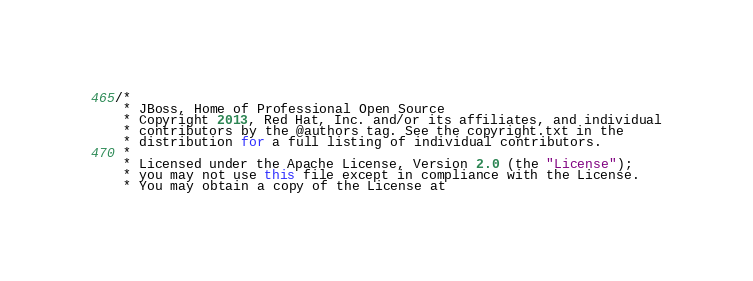Convert code to text. <code><loc_0><loc_0><loc_500><loc_500><_Java_>/*
 * JBoss, Home of Professional Open Source
 * Copyright 2013, Red Hat, Inc. and/or its affiliates, and individual
 * contributors by the @authors tag. See the copyright.txt in the
 * distribution for a full listing of individual contributors.
 *
 * Licensed under the Apache License, Version 2.0 (the "License");
 * you may not use this file except in compliance with the License.
 * You may obtain a copy of the License at</code> 